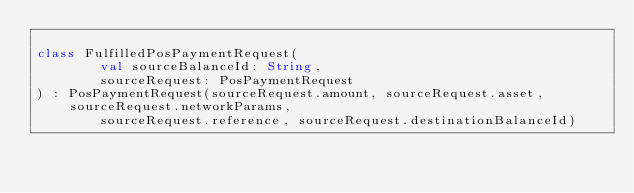<code> <loc_0><loc_0><loc_500><loc_500><_Kotlin_>
class FulfilledPosPaymentRequest(
        val sourceBalanceId: String,
        sourceRequest: PosPaymentRequest
) : PosPaymentRequest(sourceRequest.amount, sourceRequest.asset, sourceRequest.networkParams,
        sourceRequest.reference, sourceRequest.destinationBalanceId)</code> 